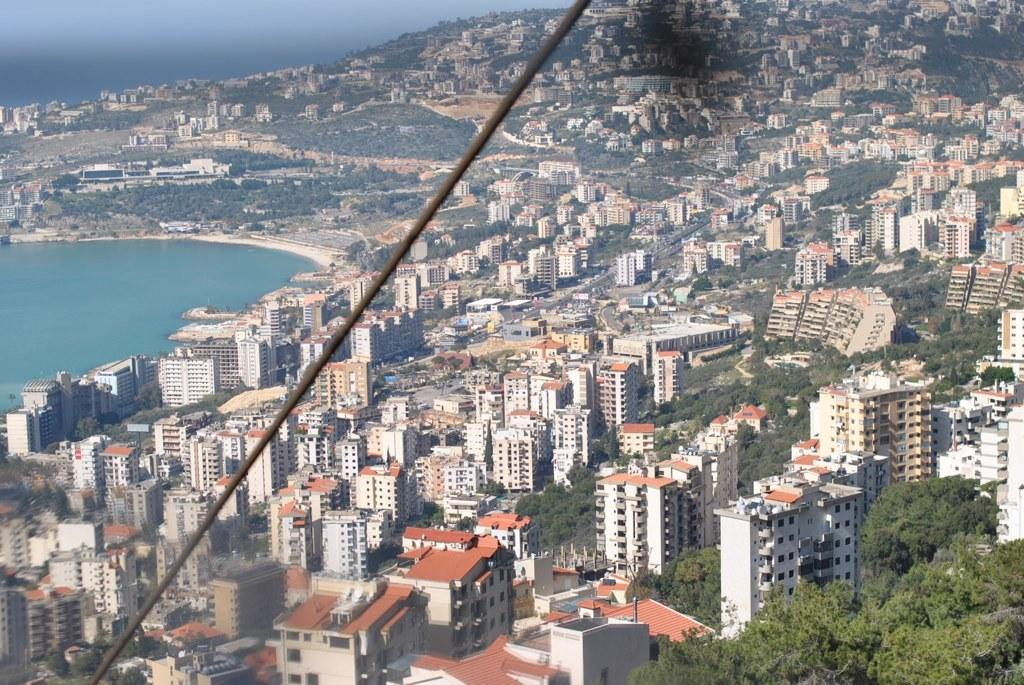What type of structures can be seen in the image? There are buildings in the image. What type of vegetation is present in the image? There are trees in the image. What natural element is visible in the image? There is water visible in the image. What object can be seen in the image that is typically used for support or guidance? There is a stick in the image. What part of the natural environment is visible in the image? The sky is visible in the image. What type of alarm can be heard going off in the image? There is no alarm present in the image, and therefore no such sound can be heard. What type of chalk is being used to write on the trees in the image? There is no chalk or writing on the trees in the image. What type of list is being compiled by the water in the image? There is no list being compiled by the water in the image. 